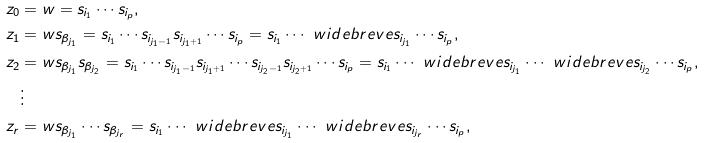<formula> <loc_0><loc_0><loc_500><loc_500>z _ { 0 } & = w = s _ { i _ { 1 } } \cdots s _ { i _ { p } } , \\ z _ { 1 } & = w s _ { \beta _ { j _ { 1 } } } = s _ { i _ { 1 } } \cdots s _ { i _ { j _ { 1 } - 1 } } s _ { i _ { j _ { 1 } + 1 } } \cdots s _ { i _ { p } } = s _ { i _ { 1 } } \cdots \ w i d e b r e v e { s _ { i _ { j _ { 1 } } } } \cdots s _ { i _ { p } } , \\ z _ { 2 } & = w s _ { \beta _ { j _ { 1 } } } s _ { \beta _ { j _ { 2 } } } = s _ { i _ { 1 } } \cdots s _ { i _ { j _ { 1 } - 1 } } s _ { i _ { j _ { 1 } + 1 } } \cdots s _ { i _ { j _ { 2 } - 1 } } s _ { i _ { j _ { 2 } + 1 } } \cdots s _ { i _ { p } } = s _ { i _ { 1 } } \cdots \ w i d e b r e v e { s _ { i _ { j _ { 1 } } } } \cdots \ w i d e b r e v e { s _ { i _ { j _ { 2 } } } } \cdots s _ { i _ { p } } , \\ & \vdots \\ z _ { r } & = w s _ { \beta _ { j _ { 1 } } } \cdots s _ { \beta _ { j _ { r } } } = s _ { i _ { 1 } } \cdots \ w i d e b r e v e { s _ { i _ { j _ { 1 } } } } \cdots \ w i d e b r e v e { s _ { i _ { j _ { r } } } } \cdots s _ { i _ { p } } ,</formula> 